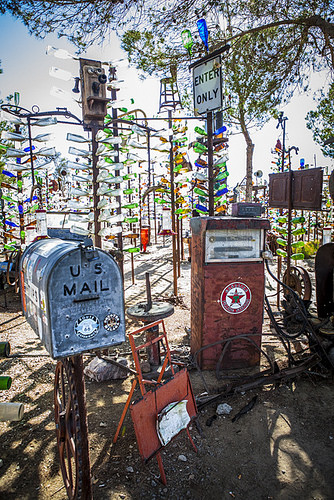<image>
Is the post box under the tree? Yes. The post box is positioned underneath the tree, with the tree above it in the vertical space. 